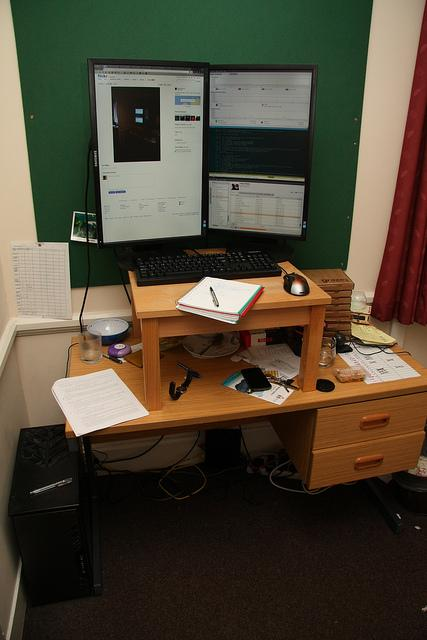Where does the black and silver item in the middle compartment belong? Please explain your reasoning. wrist. The fitness watch or fitbit fits on one's wrist. a fitness watch tracks activity and helps to monitor areas of health when worn. 